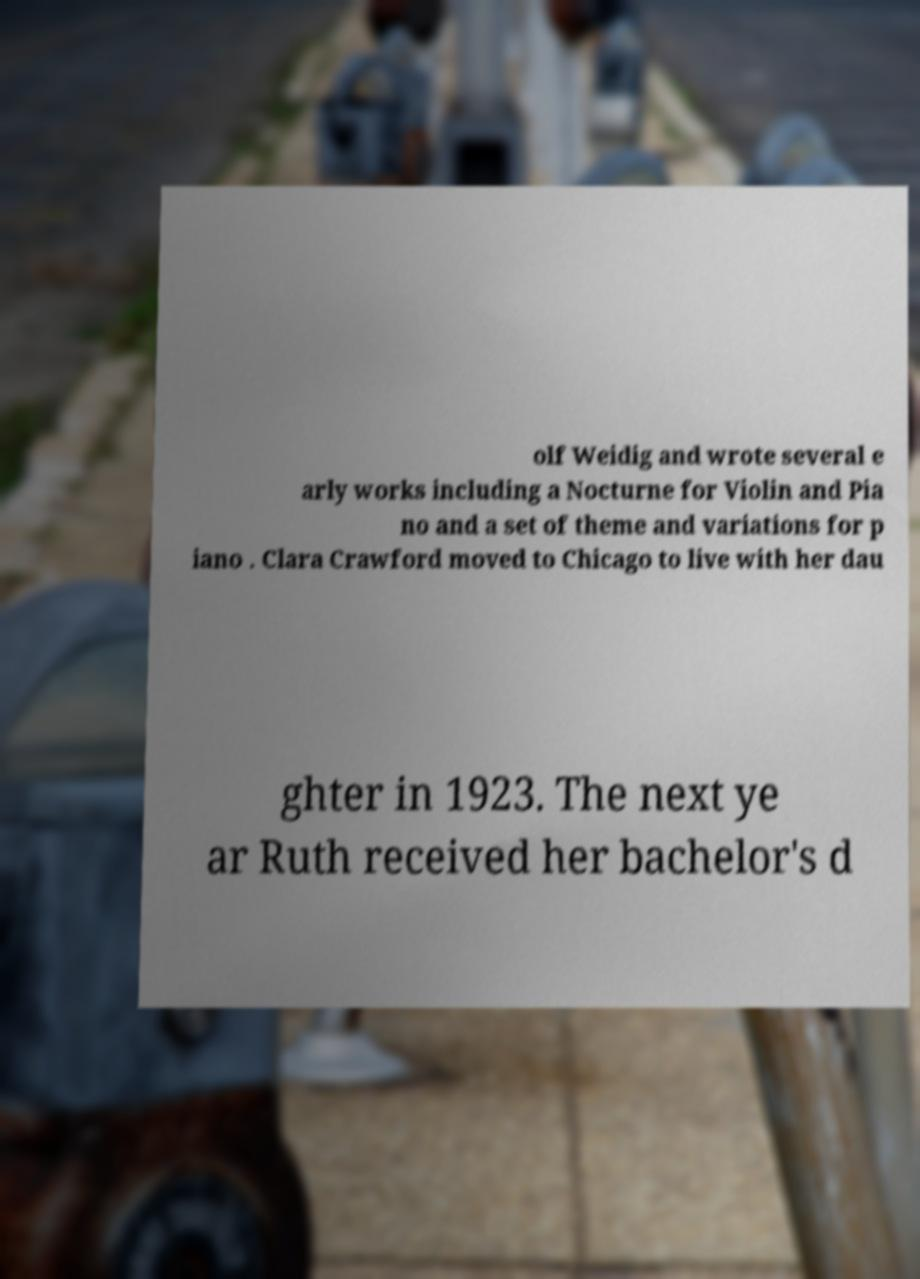Could you assist in decoding the text presented in this image and type it out clearly? olf Weidig and wrote several e arly works including a Nocturne for Violin and Pia no and a set of theme and variations for p iano . Clara Crawford moved to Chicago to live with her dau ghter in 1923. The next ye ar Ruth received her bachelor's d 